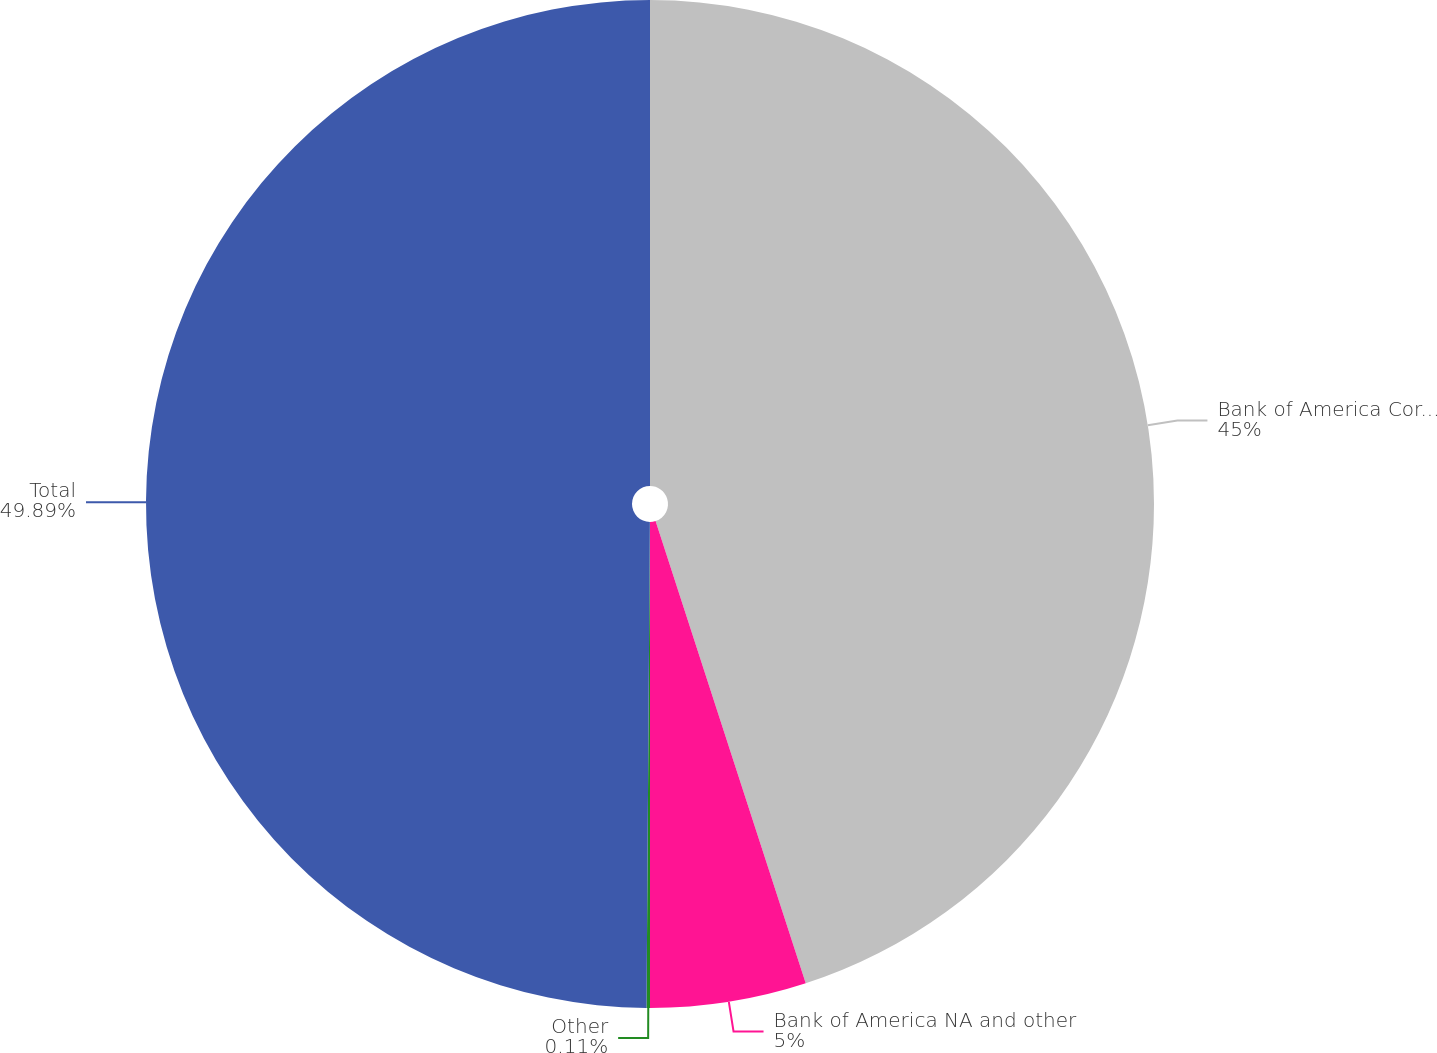<chart> <loc_0><loc_0><loc_500><loc_500><pie_chart><fcel>Bank of America Corporation<fcel>Bank of America NA and other<fcel>Other<fcel>Total<nl><fcel>45.0%<fcel>5.0%<fcel>0.11%<fcel>49.89%<nl></chart> 